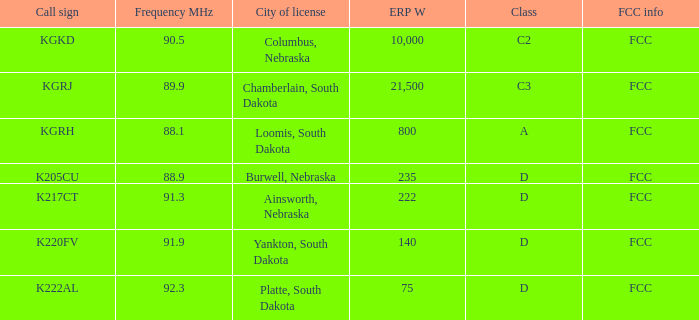Would you be able to parse every entry in this table? {'header': ['Call sign', 'Frequency MHz', 'City of license', 'ERP W', 'Class', 'FCC info'], 'rows': [['KGKD', '90.5', 'Columbus, Nebraska', '10,000', 'C2', 'FCC'], ['KGRJ', '89.9', 'Chamberlain, South Dakota', '21,500', 'C3', 'FCC'], ['KGRH', '88.1', 'Loomis, South Dakota', '800', 'A', 'FCC'], ['K205CU', '88.9', 'Burwell, Nebraska', '235', 'D', 'FCC'], ['K217CT', '91.3', 'Ainsworth, Nebraska', '222', 'D', 'FCC'], ['K220FV', '91.9', 'Yankton, South Dakota', '140', 'D', 'FCC'], ['K222AL', '92.3', 'Platte, South Dakota', '75', 'D', 'FCC']]} 9? 0.0. 